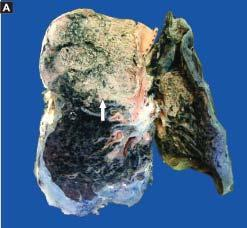does the sectioned surface of the lung show grey-brown, firm area of consolidation affecting a lobe?
Answer the question using a single word or phrase. Yes 